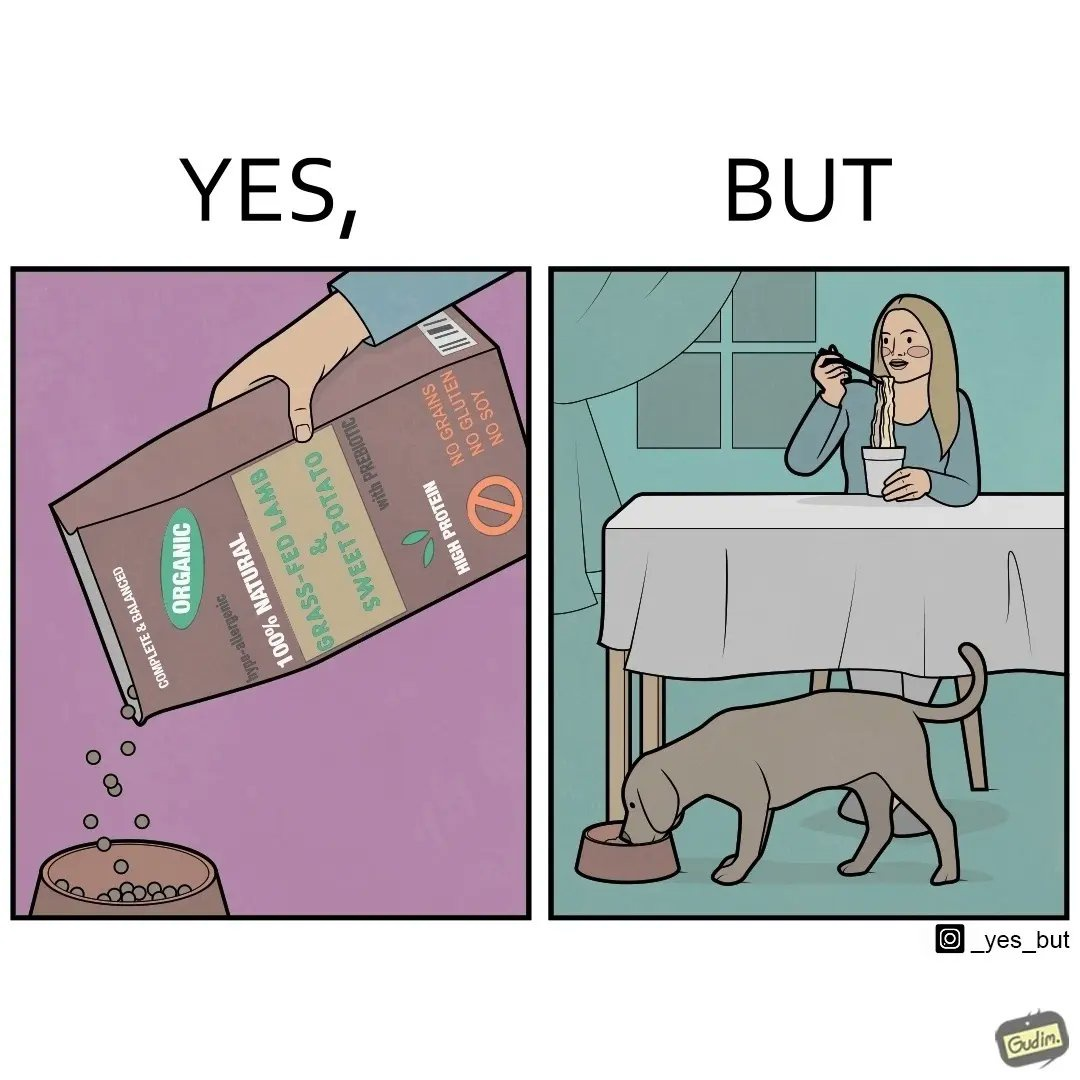Would you classify this image as satirical? Yes, this image is satirical. 